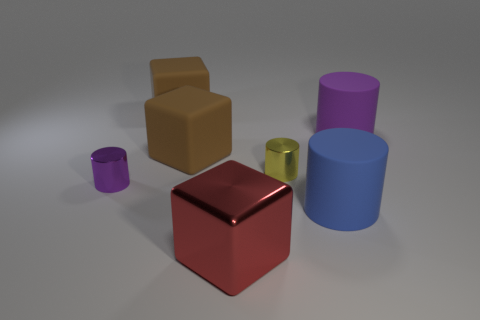Subtract all large brown matte cubes. How many cubes are left? 1 Subtract all brown cubes. How many cubes are left? 1 Add 2 big red blocks. How many objects exist? 9 Subtract 2 blocks. How many blocks are left? 1 Subtract all cubes. How many objects are left? 4 Subtract all blue cylinders. How many purple cubes are left? 0 Subtract all yellow cylinders. Subtract all red balls. How many cylinders are left? 3 Add 6 purple matte objects. How many purple matte objects are left? 7 Add 3 small purple metal things. How many small purple metal things exist? 4 Subtract 0 blue blocks. How many objects are left? 7 